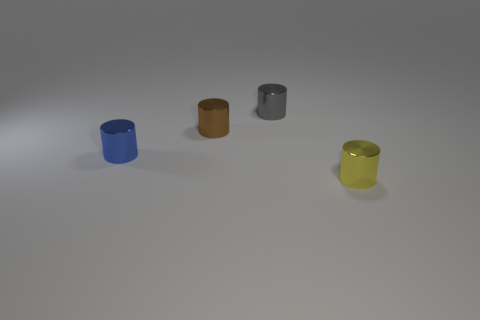How many colors can be seen in the image? There are four distinct colors visible corresponding to the four objects: blue, brown, gray, and yellow. 